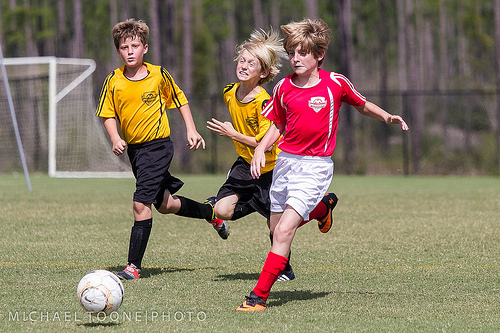<image>
Is there a ball on the ground? Yes. Looking at the image, I can see the ball is positioned on top of the ground, with the ground providing support. Is there a ball in front of the boy? Yes. The ball is positioned in front of the boy, appearing closer to the camera viewpoint. 